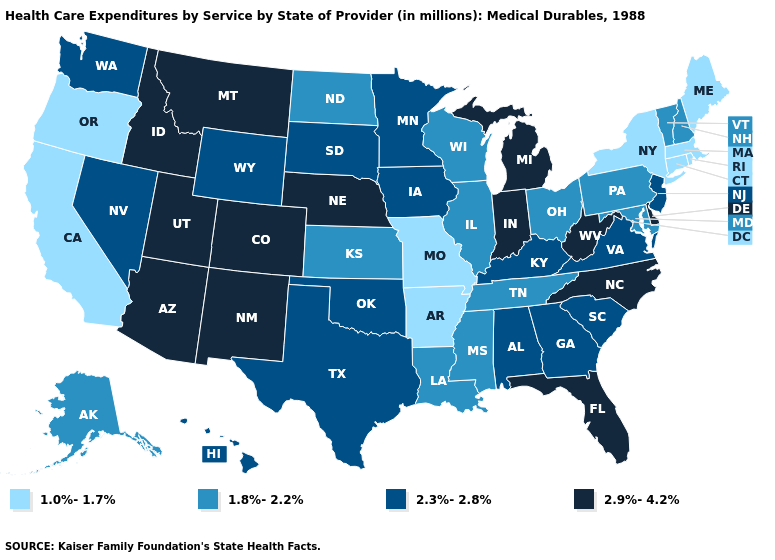How many symbols are there in the legend?
Answer briefly. 4. Does the map have missing data?
Quick response, please. No. What is the value of New York?
Concise answer only. 1.0%-1.7%. Name the states that have a value in the range 1.0%-1.7%?
Write a very short answer. Arkansas, California, Connecticut, Maine, Massachusetts, Missouri, New York, Oregon, Rhode Island. Name the states that have a value in the range 1.8%-2.2%?
Write a very short answer. Alaska, Illinois, Kansas, Louisiana, Maryland, Mississippi, New Hampshire, North Dakota, Ohio, Pennsylvania, Tennessee, Vermont, Wisconsin. What is the lowest value in states that border Oregon?
Short answer required. 1.0%-1.7%. What is the value of Arkansas?
Answer briefly. 1.0%-1.7%. What is the highest value in states that border Washington?
Answer briefly. 2.9%-4.2%. Name the states that have a value in the range 2.3%-2.8%?
Give a very brief answer. Alabama, Georgia, Hawaii, Iowa, Kentucky, Minnesota, Nevada, New Jersey, Oklahoma, South Carolina, South Dakota, Texas, Virginia, Washington, Wyoming. What is the highest value in the Northeast ?
Answer briefly. 2.3%-2.8%. Does Oregon have the highest value in the West?
Concise answer only. No. How many symbols are there in the legend?
Be succinct. 4. Does the map have missing data?
Write a very short answer. No. Name the states that have a value in the range 2.9%-4.2%?
Short answer required. Arizona, Colorado, Delaware, Florida, Idaho, Indiana, Michigan, Montana, Nebraska, New Mexico, North Carolina, Utah, West Virginia. What is the lowest value in states that border Delaware?
Quick response, please. 1.8%-2.2%. 